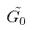Convert formula to latex. <formula><loc_0><loc_0><loc_500><loc_500>\tilde { G _ { 0 } }</formula> 